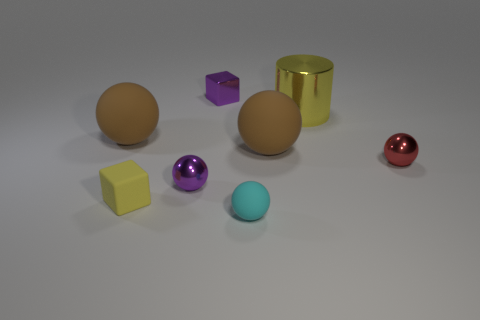There is a purple metal thing in front of the large yellow cylinder; is its size the same as the cube that is in front of the large yellow shiny thing?
Provide a succinct answer. Yes. What number of objects are tiny shiny cubes or brown objects that are on the right side of the yellow block?
Offer a terse response. 2. What is the color of the large shiny thing?
Offer a very short reply. Yellow. What material is the small ball to the right of the big brown ball that is to the right of the brown matte ball that is left of the small purple sphere?
Provide a short and direct response. Metal. There is a yellow cylinder that is made of the same material as the purple sphere; what is its size?
Give a very brief answer. Large. Are there any rubber blocks of the same color as the large cylinder?
Ensure brevity in your answer.  Yes. Do the cyan object and the thing that is to the right of the yellow cylinder have the same size?
Offer a very short reply. Yes. There is a small shiny thing in front of the tiny metallic sphere that is on the right side of the cylinder; how many big rubber things are left of it?
Keep it short and to the point. 1. There is a matte block that is the same color as the big metal object; what is its size?
Offer a very short reply. Small. There is a small red metallic sphere; are there any yellow objects left of it?
Your answer should be very brief. Yes. 